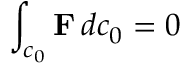Convert formula to latex. <formula><loc_0><loc_0><loc_500><loc_500>\int _ { c _ { 0 } } F \, d c _ { 0 } = 0</formula> 